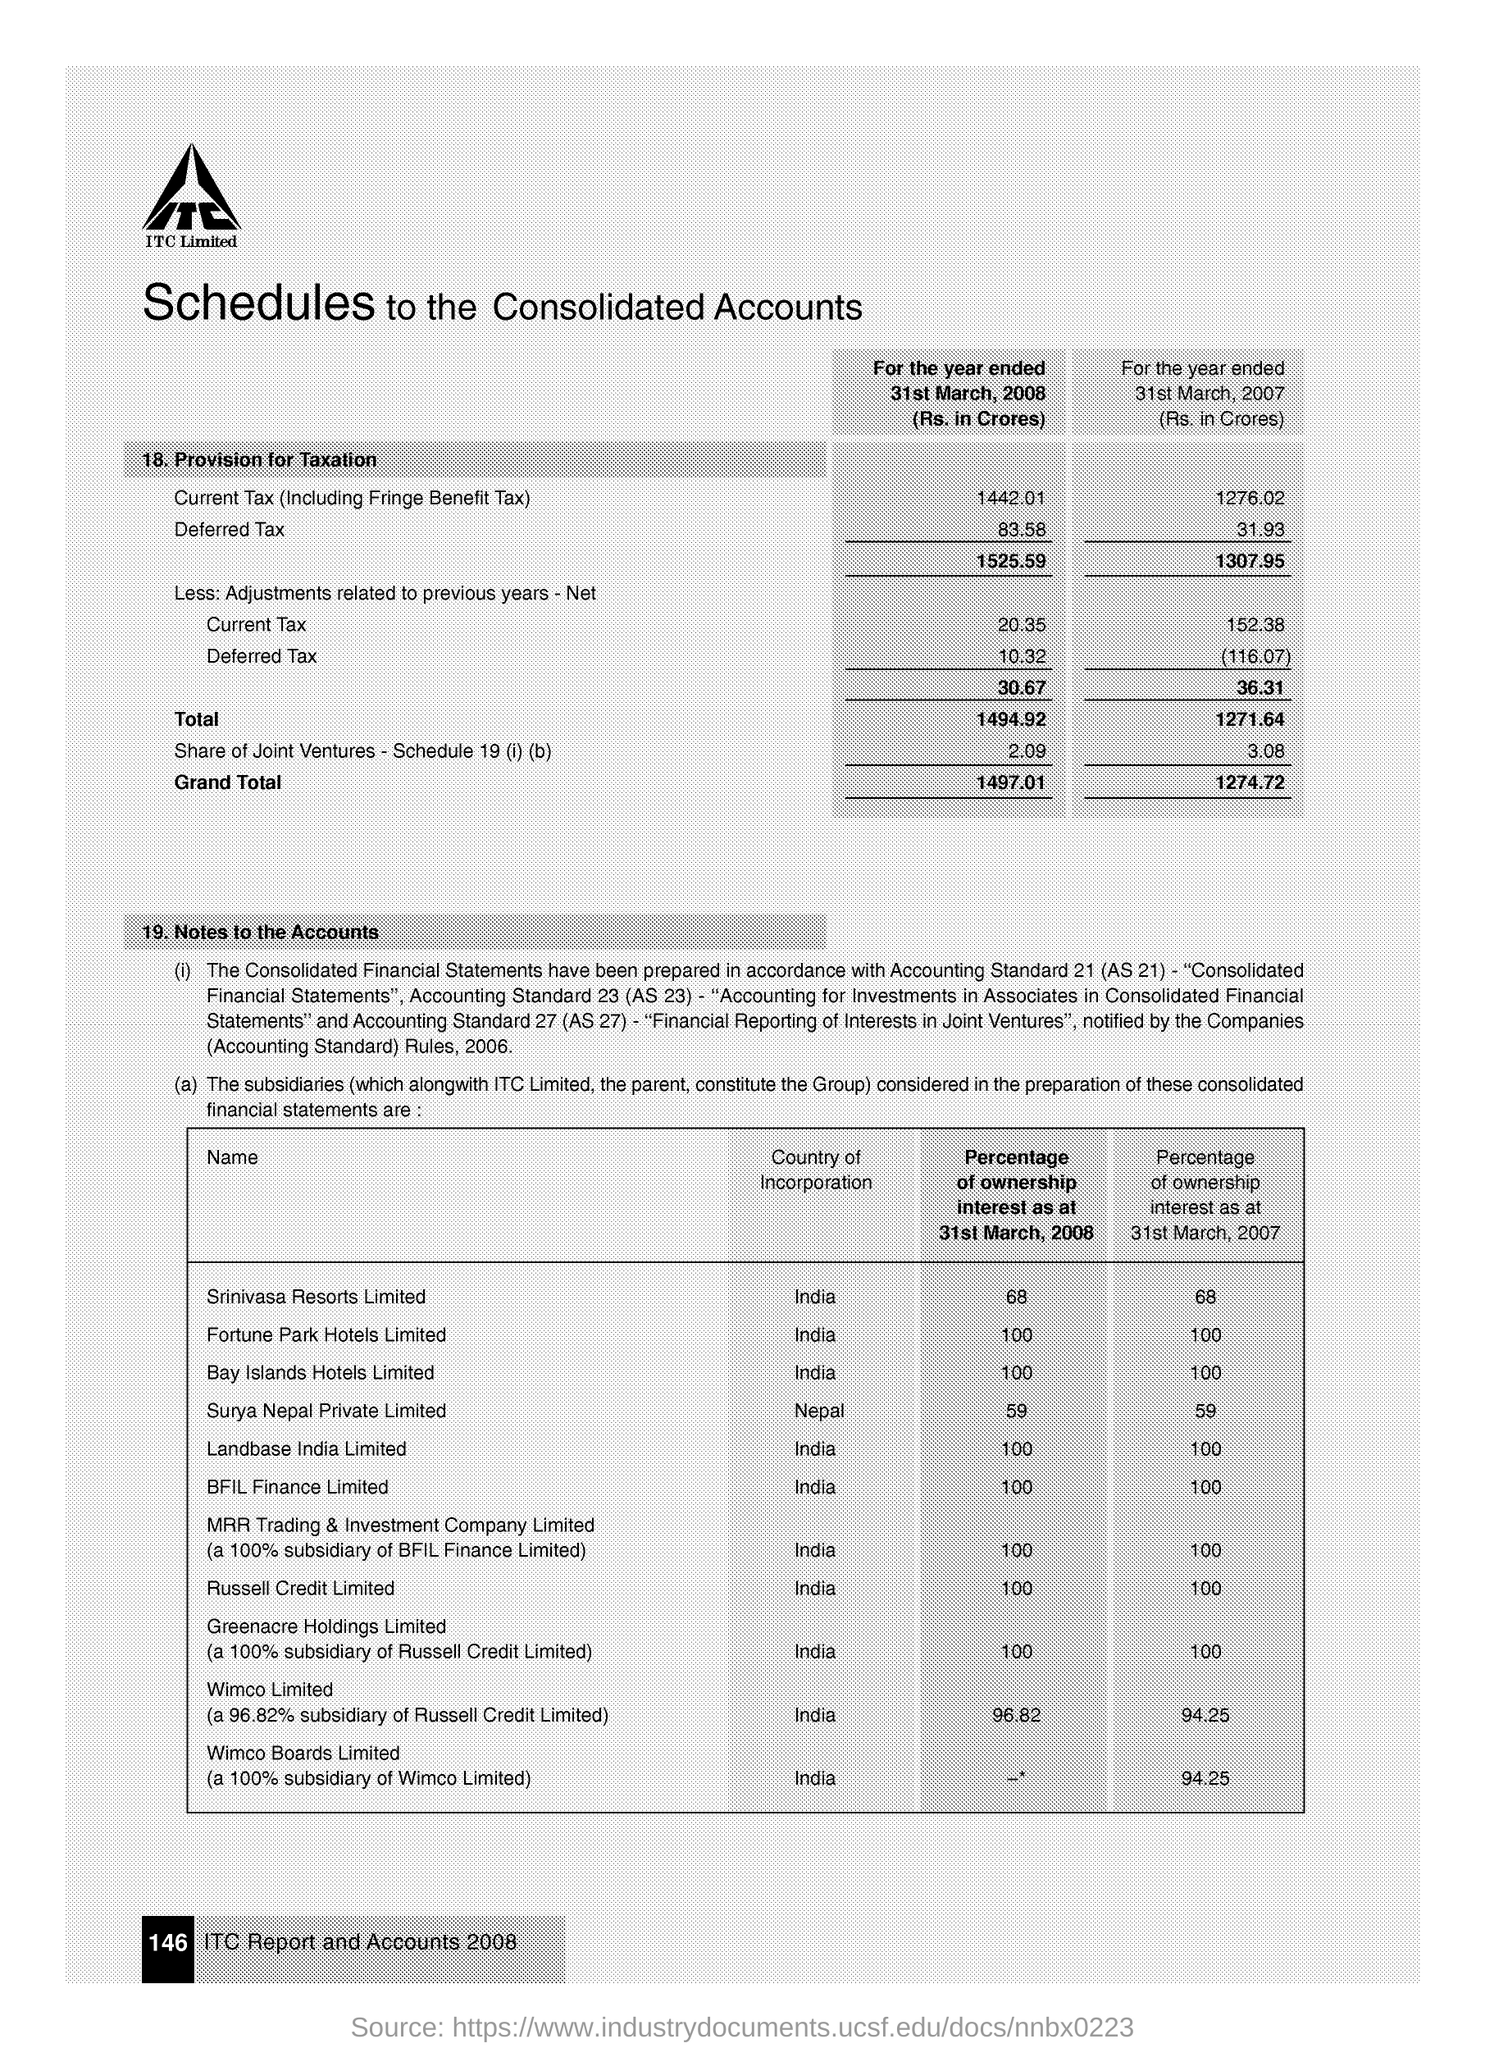What is the Deferred Tax for the year ended 31st March, 2008 (Rs. in Crores)?
Your answer should be compact. 83.58. Which is the Country of Incorporation of Srinivasa Resorts Limited?
Your answer should be compact. India. 